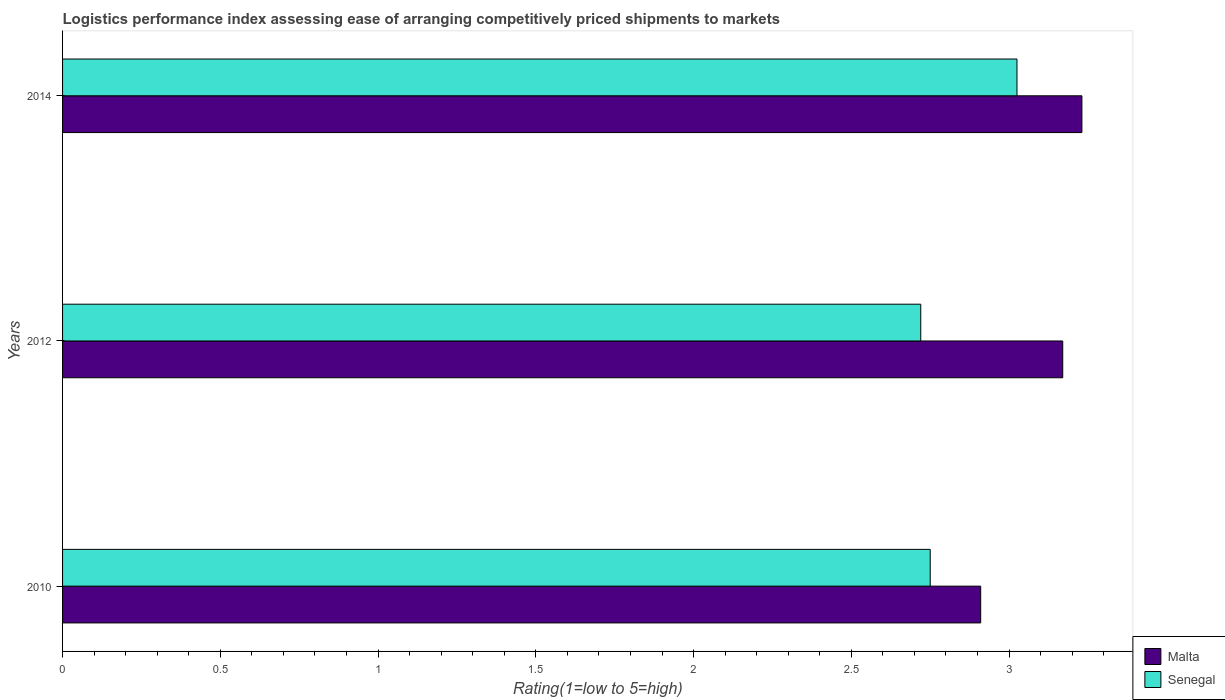How many groups of bars are there?
Offer a terse response. 3. Are the number of bars per tick equal to the number of legend labels?
Provide a short and direct response. Yes. How many bars are there on the 2nd tick from the top?
Ensure brevity in your answer.  2. How many bars are there on the 3rd tick from the bottom?
Your answer should be compact. 2. What is the label of the 1st group of bars from the top?
Make the answer very short. 2014. In how many cases, is the number of bars for a given year not equal to the number of legend labels?
Provide a short and direct response. 0. What is the Logistic performance index in Senegal in 2014?
Offer a terse response. 3.02. Across all years, what is the maximum Logistic performance index in Senegal?
Offer a terse response. 3.02. Across all years, what is the minimum Logistic performance index in Senegal?
Provide a short and direct response. 2.72. What is the total Logistic performance index in Senegal in the graph?
Your answer should be very brief. 8.5. What is the difference between the Logistic performance index in Malta in 2010 and that in 2014?
Offer a very short reply. -0.32. What is the difference between the Logistic performance index in Senegal in 2010 and the Logistic performance index in Malta in 2014?
Your answer should be very brief. -0.48. What is the average Logistic performance index in Senegal per year?
Keep it short and to the point. 2.83. In the year 2010, what is the difference between the Logistic performance index in Senegal and Logistic performance index in Malta?
Your answer should be very brief. -0.16. In how many years, is the Logistic performance index in Senegal greater than 1.7 ?
Make the answer very short. 3. What is the ratio of the Logistic performance index in Malta in 2010 to that in 2012?
Keep it short and to the point. 0.92. Is the Logistic performance index in Senegal in 2010 less than that in 2012?
Your answer should be very brief. No. What is the difference between the highest and the second highest Logistic performance index in Malta?
Make the answer very short. 0.06. What is the difference between the highest and the lowest Logistic performance index in Malta?
Your answer should be very brief. 0.32. In how many years, is the Logistic performance index in Senegal greater than the average Logistic performance index in Senegal taken over all years?
Keep it short and to the point. 1. What does the 2nd bar from the top in 2012 represents?
Offer a very short reply. Malta. What does the 1st bar from the bottom in 2010 represents?
Make the answer very short. Malta. How many bars are there?
Give a very brief answer. 6. What is the difference between two consecutive major ticks on the X-axis?
Offer a very short reply. 0.5. Does the graph contain grids?
Provide a succinct answer. No. What is the title of the graph?
Offer a terse response. Logistics performance index assessing ease of arranging competitively priced shipments to markets. What is the label or title of the X-axis?
Your answer should be very brief. Rating(1=low to 5=high). What is the label or title of the Y-axis?
Make the answer very short. Years. What is the Rating(1=low to 5=high) of Malta in 2010?
Make the answer very short. 2.91. What is the Rating(1=low to 5=high) of Senegal in 2010?
Your response must be concise. 2.75. What is the Rating(1=low to 5=high) of Malta in 2012?
Give a very brief answer. 3.17. What is the Rating(1=low to 5=high) in Senegal in 2012?
Your answer should be very brief. 2.72. What is the Rating(1=low to 5=high) in Malta in 2014?
Offer a terse response. 3.23. What is the Rating(1=low to 5=high) of Senegal in 2014?
Keep it short and to the point. 3.02. Across all years, what is the maximum Rating(1=low to 5=high) in Malta?
Offer a very short reply. 3.23. Across all years, what is the maximum Rating(1=low to 5=high) in Senegal?
Provide a short and direct response. 3.02. Across all years, what is the minimum Rating(1=low to 5=high) in Malta?
Ensure brevity in your answer.  2.91. Across all years, what is the minimum Rating(1=low to 5=high) in Senegal?
Offer a terse response. 2.72. What is the total Rating(1=low to 5=high) of Malta in the graph?
Make the answer very short. 9.31. What is the total Rating(1=low to 5=high) in Senegal in the graph?
Your answer should be compact. 8.49. What is the difference between the Rating(1=low to 5=high) in Malta in 2010 and that in 2012?
Provide a short and direct response. -0.26. What is the difference between the Rating(1=low to 5=high) in Senegal in 2010 and that in 2012?
Ensure brevity in your answer.  0.03. What is the difference between the Rating(1=low to 5=high) of Malta in 2010 and that in 2014?
Keep it short and to the point. -0.32. What is the difference between the Rating(1=low to 5=high) of Senegal in 2010 and that in 2014?
Provide a short and direct response. -0.28. What is the difference between the Rating(1=low to 5=high) of Malta in 2012 and that in 2014?
Your answer should be compact. -0.06. What is the difference between the Rating(1=low to 5=high) of Senegal in 2012 and that in 2014?
Make the answer very short. -0.3. What is the difference between the Rating(1=low to 5=high) of Malta in 2010 and the Rating(1=low to 5=high) of Senegal in 2012?
Provide a short and direct response. 0.19. What is the difference between the Rating(1=low to 5=high) in Malta in 2010 and the Rating(1=low to 5=high) in Senegal in 2014?
Your answer should be compact. -0.12. What is the difference between the Rating(1=low to 5=high) in Malta in 2012 and the Rating(1=low to 5=high) in Senegal in 2014?
Offer a terse response. 0.14. What is the average Rating(1=low to 5=high) in Malta per year?
Your response must be concise. 3.1. What is the average Rating(1=low to 5=high) in Senegal per year?
Provide a succinct answer. 2.83. In the year 2010, what is the difference between the Rating(1=low to 5=high) in Malta and Rating(1=low to 5=high) in Senegal?
Ensure brevity in your answer.  0.16. In the year 2012, what is the difference between the Rating(1=low to 5=high) in Malta and Rating(1=low to 5=high) in Senegal?
Give a very brief answer. 0.45. In the year 2014, what is the difference between the Rating(1=low to 5=high) of Malta and Rating(1=low to 5=high) of Senegal?
Ensure brevity in your answer.  0.21. What is the ratio of the Rating(1=low to 5=high) of Malta in 2010 to that in 2012?
Give a very brief answer. 0.92. What is the ratio of the Rating(1=low to 5=high) of Senegal in 2010 to that in 2012?
Provide a succinct answer. 1.01. What is the ratio of the Rating(1=low to 5=high) in Malta in 2010 to that in 2014?
Keep it short and to the point. 0.9. What is the ratio of the Rating(1=low to 5=high) of Senegal in 2010 to that in 2014?
Provide a succinct answer. 0.91. What is the ratio of the Rating(1=low to 5=high) in Malta in 2012 to that in 2014?
Provide a short and direct response. 0.98. What is the ratio of the Rating(1=low to 5=high) in Senegal in 2012 to that in 2014?
Your answer should be very brief. 0.9. What is the difference between the highest and the second highest Rating(1=low to 5=high) of Malta?
Give a very brief answer. 0.06. What is the difference between the highest and the second highest Rating(1=low to 5=high) in Senegal?
Provide a succinct answer. 0.28. What is the difference between the highest and the lowest Rating(1=low to 5=high) of Malta?
Ensure brevity in your answer.  0.32. What is the difference between the highest and the lowest Rating(1=low to 5=high) of Senegal?
Make the answer very short. 0.3. 